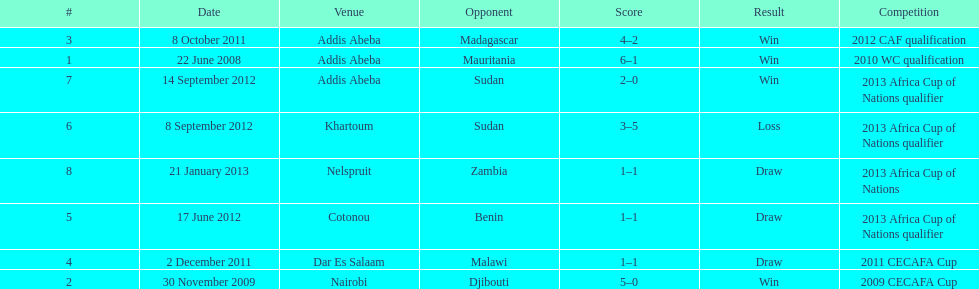True or false? in comparison, the ethiopian national team has more draws than wins. False. 